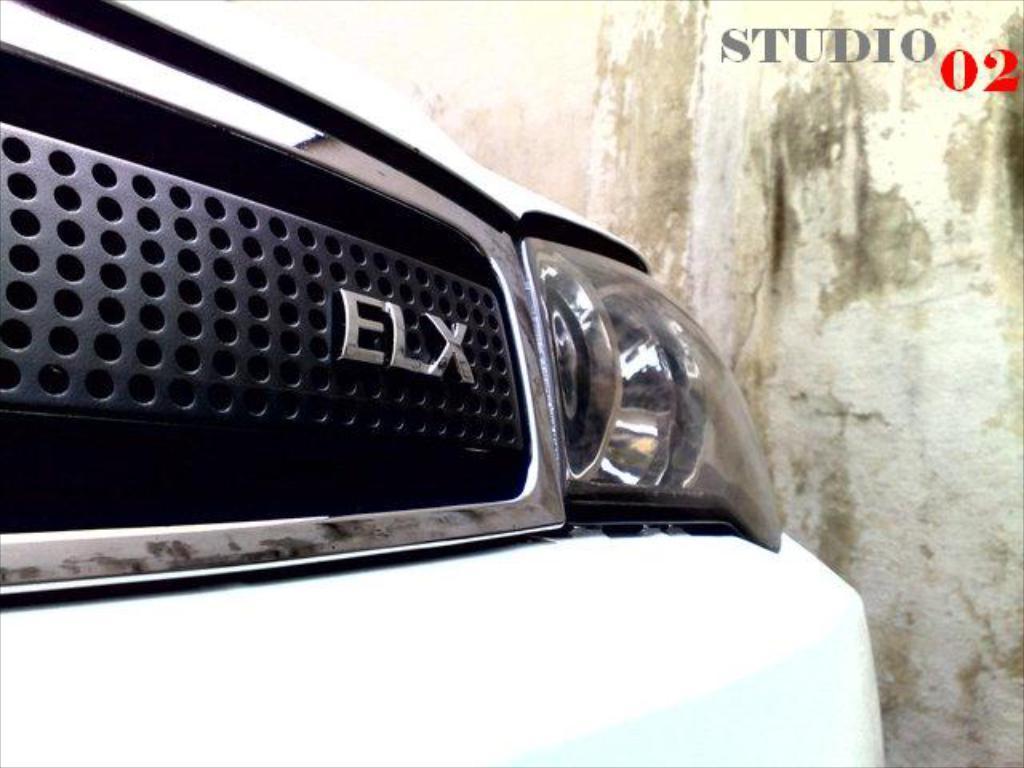Could you give a brief overview of what you see in this image? In the center of the image we can see car. In the background there is wall. 